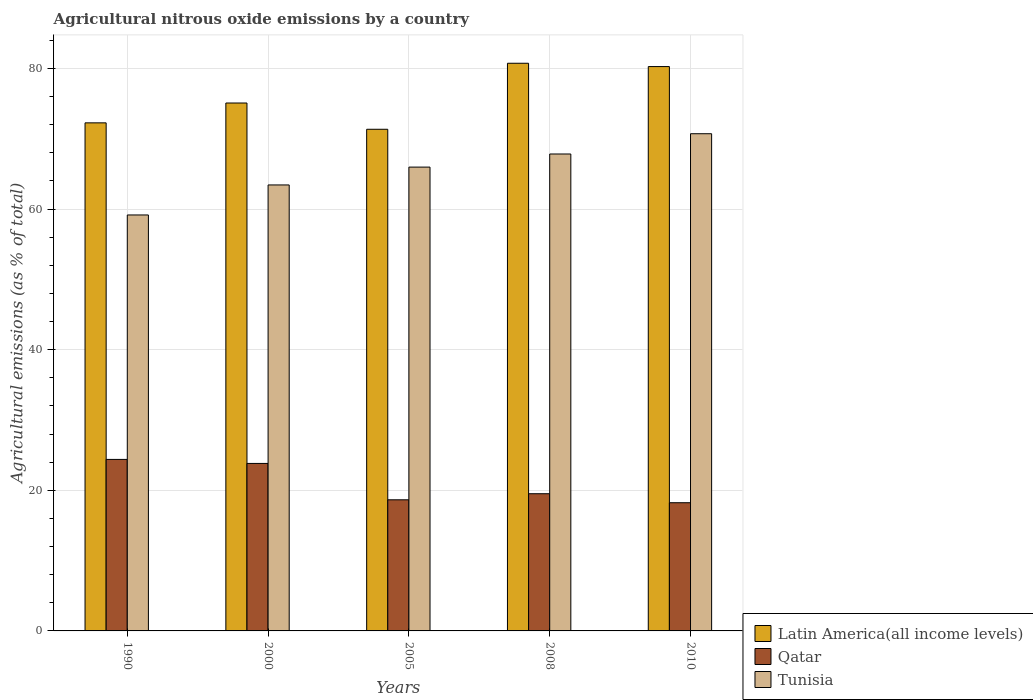How many groups of bars are there?
Your response must be concise. 5. Are the number of bars on each tick of the X-axis equal?
Give a very brief answer. Yes. How many bars are there on the 5th tick from the left?
Offer a terse response. 3. What is the label of the 3rd group of bars from the left?
Your answer should be very brief. 2005. What is the amount of agricultural nitrous oxide emitted in Qatar in 2010?
Ensure brevity in your answer.  18.23. Across all years, what is the maximum amount of agricultural nitrous oxide emitted in Latin America(all income levels)?
Offer a terse response. 80.73. Across all years, what is the minimum amount of agricultural nitrous oxide emitted in Qatar?
Keep it short and to the point. 18.23. What is the total amount of agricultural nitrous oxide emitted in Tunisia in the graph?
Offer a very short reply. 327.08. What is the difference between the amount of agricultural nitrous oxide emitted in Tunisia in 2005 and that in 2008?
Offer a terse response. -1.86. What is the difference between the amount of agricultural nitrous oxide emitted in Qatar in 2008 and the amount of agricultural nitrous oxide emitted in Tunisia in 1990?
Offer a very short reply. -39.64. What is the average amount of agricultural nitrous oxide emitted in Latin America(all income levels) per year?
Give a very brief answer. 75.93. In the year 2005, what is the difference between the amount of agricultural nitrous oxide emitted in Qatar and amount of agricultural nitrous oxide emitted in Tunisia?
Provide a succinct answer. -47.31. In how many years, is the amount of agricultural nitrous oxide emitted in Tunisia greater than 72 %?
Your answer should be very brief. 0. What is the ratio of the amount of agricultural nitrous oxide emitted in Latin America(all income levels) in 1990 to that in 2005?
Ensure brevity in your answer.  1.01. Is the difference between the amount of agricultural nitrous oxide emitted in Qatar in 1990 and 2010 greater than the difference between the amount of agricultural nitrous oxide emitted in Tunisia in 1990 and 2010?
Keep it short and to the point. Yes. What is the difference between the highest and the second highest amount of agricultural nitrous oxide emitted in Qatar?
Your answer should be very brief. 0.57. What is the difference between the highest and the lowest amount of agricultural nitrous oxide emitted in Tunisia?
Offer a very short reply. 11.55. In how many years, is the amount of agricultural nitrous oxide emitted in Tunisia greater than the average amount of agricultural nitrous oxide emitted in Tunisia taken over all years?
Your answer should be very brief. 3. What does the 2nd bar from the left in 2005 represents?
Ensure brevity in your answer.  Qatar. What does the 2nd bar from the right in 2005 represents?
Keep it short and to the point. Qatar. How many years are there in the graph?
Offer a very short reply. 5. Does the graph contain any zero values?
Offer a very short reply. No. Does the graph contain grids?
Provide a succinct answer. Yes. How many legend labels are there?
Offer a terse response. 3. How are the legend labels stacked?
Offer a very short reply. Vertical. What is the title of the graph?
Your answer should be very brief. Agricultural nitrous oxide emissions by a country. What is the label or title of the Y-axis?
Give a very brief answer. Agricultural emissions (as % of total). What is the Agricultural emissions (as % of total) of Latin America(all income levels) in 1990?
Offer a very short reply. 72.26. What is the Agricultural emissions (as % of total) in Qatar in 1990?
Ensure brevity in your answer.  24.39. What is the Agricultural emissions (as % of total) in Tunisia in 1990?
Give a very brief answer. 59.15. What is the Agricultural emissions (as % of total) in Latin America(all income levels) in 2000?
Provide a succinct answer. 75.08. What is the Agricultural emissions (as % of total) of Qatar in 2000?
Your answer should be very brief. 23.82. What is the Agricultural emissions (as % of total) in Tunisia in 2000?
Give a very brief answer. 63.42. What is the Agricultural emissions (as % of total) in Latin America(all income levels) in 2005?
Your response must be concise. 71.34. What is the Agricultural emissions (as % of total) of Qatar in 2005?
Offer a very short reply. 18.65. What is the Agricultural emissions (as % of total) in Tunisia in 2005?
Provide a short and direct response. 65.96. What is the Agricultural emissions (as % of total) in Latin America(all income levels) in 2008?
Ensure brevity in your answer.  80.73. What is the Agricultural emissions (as % of total) of Qatar in 2008?
Your response must be concise. 19.51. What is the Agricultural emissions (as % of total) in Tunisia in 2008?
Your answer should be very brief. 67.83. What is the Agricultural emissions (as % of total) of Latin America(all income levels) in 2010?
Make the answer very short. 80.26. What is the Agricultural emissions (as % of total) of Qatar in 2010?
Your answer should be compact. 18.23. What is the Agricultural emissions (as % of total) of Tunisia in 2010?
Give a very brief answer. 70.71. Across all years, what is the maximum Agricultural emissions (as % of total) of Latin America(all income levels)?
Keep it short and to the point. 80.73. Across all years, what is the maximum Agricultural emissions (as % of total) in Qatar?
Provide a short and direct response. 24.39. Across all years, what is the maximum Agricultural emissions (as % of total) of Tunisia?
Your answer should be compact. 70.71. Across all years, what is the minimum Agricultural emissions (as % of total) in Latin America(all income levels)?
Ensure brevity in your answer.  71.34. Across all years, what is the minimum Agricultural emissions (as % of total) in Qatar?
Ensure brevity in your answer.  18.23. Across all years, what is the minimum Agricultural emissions (as % of total) in Tunisia?
Provide a succinct answer. 59.15. What is the total Agricultural emissions (as % of total) of Latin America(all income levels) in the graph?
Your answer should be very brief. 379.66. What is the total Agricultural emissions (as % of total) in Qatar in the graph?
Offer a very short reply. 104.6. What is the total Agricultural emissions (as % of total) in Tunisia in the graph?
Ensure brevity in your answer.  327.08. What is the difference between the Agricultural emissions (as % of total) of Latin America(all income levels) in 1990 and that in 2000?
Give a very brief answer. -2.82. What is the difference between the Agricultural emissions (as % of total) of Qatar in 1990 and that in 2000?
Make the answer very short. 0.57. What is the difference between the Agricultural emissions (as % of total) in Tunisia in 1990 and that in 2000?
Provide a succinct answer. -4.27. What is the difference between the Agricultural emissions (as % of total) in Latin America(all income levels) in 1990 and that in 2005?
Ensure brevity in your answer.  0.91. What is the difference between the Agricultural emissions (as % of total) of Qatar in 1990 and that in 2005?
Your response must be concise. 5.74. What is the difference between the Agricultural emissions (as % of total) of Tunisia in 1990 and that in 2005?
Provide a short and direct response. -6.81. What is the difference between the Agricultural emissions (as % of total) of Latin America(all income levels) in 1990 and that in 2008?
Give a very brief answer. -8.47. What is the difference between the Agricultural emissions (as % of total) of Qatar in 1990 and that in 2008?
Make the answer very short. 4.88. What is the difference between the Agricultural emissions (as % of total) in Tunisia in 1990 and that in 2008?
Give a very brief answer. -8.67. What is the difference between the Agricultural emissions (as % of total) of Latin America(all income levels) in 1990 and that in 2010?
Ensure brevity in your answer.  -8. What is the difference between the Agricultural emissions (as % of total) of Qatar in 1990 and that in 2010?
Offer a very short reply. 6.16. What is the difference between the Agricultural emissions (as % of total) of Tunisia in 1990 and that in 2010?
Ensure brevity in your answer.  -11.55. What is the difference between the Agricultural emissions (as % of total) of Latin America(all income levels) in 2000 and that in 2005?
Offer a very short reply. 3.74. What is the difference between the Agricultural emissions (as % of total) in Qatar in 2000 and that in 2005?
Keep it short and to the point. 5.17. What is the difference between the Agricultural emissions (as % of total) of Tunisia in 2000 and that in 2005?
Your response must be concise. -2.54. What is the difference between the Agricultural emissions (as % of total) in Latin America(all income levels) in 2000 and that in 2008?
Offer a very short reply. -5.65. What is the difference between the Agricultural emissions (as % of total) in Qatar in 2000 and that in 2008?
Offer a very short reply. 4.31. What is the difference between the Agricultural emissions (as % of total) of Tunisia in 2000 and that in 2008?
Ensure brevity in your answer.  -4.4. What is the difference between the Agricultural emissions (as % of total) in Latin America(all income levels) in 2000 and that in 2010?
Your answer should be very brief. -5.18. What is the difference between the Agricultural emissions (as % of total) in Qatar in 2000 and that in 2010?
Keep it short and to the point. 5.59. What is the difference between the Agricultural emissions (as % of total) in Tunisia in 2000 and that in 2010?
Provide a succinct answer. -7.28. What is the difference between the Agricultural emissions (as % of total) in Latin America(all income levels) in 2005 and that in 2008?
Your answer should be very brief. -9.39. What is the difference between the Agricultural emissions (as % of total) of Qatar in 2005 and that in 2008?
Ensure brevity in your answer.  -0.86. What is the difference between the Agricultural emissions (as % of total) in Tunisia in 2005 and that in 2008?
Your answer should be compact. -1.86. What is the difference between the Agricultural emissions (as % of total) in Latin America(all income levels) in 2005 and that in 2010?
Your answer should be compact. -8.92. What is the difference between the Agricultural emissions (as % of total) in Qatar in 2005 and that in 2010?
Your answer should be compact. 0.42. What is the difference between the Agricultural emissions (as % of total) of Tunisia in 2005 and that in 2010?
Your response must be concise. -4.75. What is the difference between the Agricultural emissions (as % of total) of Latin America(all income levels) in 2008 and that in 2010?
Provide a succinct answer. 0.47. What is the difference between the Agricultural emissions (as % of total) of Qatar in 2008 and that in 2010?
Ensure brevity in your answer.  1.28. What is the difference between the Agricultural emissions (as % of total) in Tunisia in 2008 and that in 2010?
Offer a very short reply. -2.88. What is the difference between the Agricultural emissions (as % of total) of Latin America(all income levels) in 1990 and the Agricultural emissions (as % of total) of Qatar in 2000?
Provide a succinct answer. 48.43. What is the difference between the Agricultural emissions (as % of total) of Latin America(all income levels) in 1990 and the Agricultural emissions (as % of total) of Tunisia in 2000?
Make the answer very short. 8.83. What is the difference between the Agricultural emissions (as % of total) of Qatar in 1990 and the Agricultural emissions (as % of total) of Tunisia in 2000?
Your response must be concise. -39.03. What is the difference between the Agricultural emissions (as % of total) in Latin America(all income levels) in 1990 and the Agricultural emissions (as % of total) in Qatar in 2005?
Offer a very short reply. 53.61. What is the difference between the Agricultural emissions (as % of total) of Latin America(all income levels) in 1990 and the Agricultural emissions (as % of total) of Tunisia in 2005?
Your response must be concise. 6.29. What is the difference between the Agricultural emissions (as % of total) of Qatar in 1990 and the Agricultural emissions (as % of total) of Tunisia in 2005?
Give a very brief answer. -41.57. What is the difference between the Agricultural emissions (as % of total) of Latin America(all income levels) in 1990 and the Agricultural emissions (as % of total) of Qatar in 2008?
Offer a terse response. 52.74. What is the difference between the Agricultural emissions (as % of total) in Latin America(all income levels) in 1990 and the Agricultural emissions (as % of total) in Tunisia in 2008?
Offer a terse response. 4.43. What is the difference between the Agricultural emissions (as % of total) in Qatar in 1990 and the Agricultural emissions (as % of total) in Tunisia in 2008?
Give a very brief answer. -43.44. What is the difference between the Agricultural emissions (as % of total) of Latin America(all income levels) in 1990 and the Agricultural emissions (as % of total) of Qatar in 2010?
Offer a terse response. 54.02. What is the difference between the Agricultural emissions (as % of total) in Latin America(all income levels) in 1990 and the Agricultural emissions (as % of total) in Tunisia in 2010?
Provide a short and direct response. 1.55. What is the difference between the Agricultural emissions (as % of total) in Qatar in 1990 and the Agricultural emissions (as % of total) in Tunisia in 2010?
Your answer should be very brief. -46.32. What is the difference between the Agricultural emissions (as % of total) in Latin America(all income levels) in 2000 and the Agricultural emissions (as % of total) in Qatar in 2005?
Give a very brief answer. 56.43. What is the difference between the Agricultural emissions (as % of total) of Latin America(all income levels) in 2000 and the Agricultural emissions (as % of total) of Tunisia in 2005?
Keep it short and to the point. 9.12. What is the difference between the Agricultural emissions (as % of total) of Qatar in 2000 and the Agricultural emissions (as % of total) of Tunisia in 2005?
Keep it short and to the point. -42.14. What is the difference between the Agricultural emissions (as % of total) of Latin America(all income levels) in 2000 and the Agricultural emissions (as % of total) of Qatar in 2008?
Offer a terse response. 55.57. What is the difference between the Agricultural emissions (as % of total) in Latin America(all income levels) in 2000 and the Agricultural emissions (as % of total) in Tunisia in 2008?
Your response must be concise. 7.25. What is the difference between the Agricultural emissions (as % of total) of Qatar in 2000 and the Agricultural emissions (as % of total) of Tunisia in 2008?
Make the answer very short. -44.01. What is the difference between the Agricultural emissions (as % of total) in Latin America(all income levels) in 2000 and the Agricultural emissions (as % of total) in Qatar in 2010?
Make the answer very short. 56.85. What is the difference between the Agricultural emissions (as % of total) of Latin America(all income levels) in 2000 and the Agricultural emissions (as % of total) of Tunisia in 2010?
Your answer should be very brief. 4.37. What is the difference between the Agricultural emissions (as % of total) of Qatar in 2000 and the Agricultural emissions (as % of total) of Tunisia in 2010?
Ensure brevity in your answer.  -46.89. What is the difference between the Agricultural emissions (as % of total) in Latin America(all income levels) in 2005 and the Agricultural emissions (as % of total) in Qatar in 2008?
Provide a succinct answer. 51.83. What is the difference between the Agricultural emissions (as % of total) in Latin America(all income levels) in 2005 and the Agricultural emissions (as % of total) in Tunisia in 2008?
Provide a succinct answer. 3.52. What is the difference between the Agricultural emissions (as % of total) in Qatar in 2005 and the Agricultural emissions (as % of total) in Tunisia in 2008?
Keep it short and to the point. -49.18. What is the difference between the Agricultural emissions (as % of total) in Latin America(all income levels) in 2005 and the Agricultural emissions (as % of total) in Qatar in 2010?
Ensure brevity in your answer.  53.11. What is the difference between the Agricultural emissions (as % of total) in Latin America(all income levels) in 2005 and the Agricultural emissions (as % of total) in Tunisia in 2010?
Give a very brief answer. 0.63. What is the difference between the Agricultural emissions (as % of total) in Qatar in 2005 and the Agricultural emissions (as % of total) in Tunisia in 2010?
Your answer should be compact. -52.06. What is the difference between the Agricultural emissions (as % of total) in Latin America(all income levels) in 2008 and the Agricultural emissions (as % of total) in Qatar in 2010?
Your answer should be compact. 62.5. What is the difference between the Agricultural emissions (as % of total) in Latin America(all income levels) in 2008 and the Agricultural emissions (as % of total) in Tunisia in 2010?
Provide a short and direct response. 10.02. What is the difference between the Agricultural emissions (as % of total) in Qatar in 2008 and the Agricultural emissions (as % of total) in Tunisia in 2010?
Provide a succinct answer. -51.2. What is the average Agricultural emissions (as % of total) in Latin America(all income levels) per year?
Ensure brevity in your answer.  75.93. What is the average Agricultural emissions (as % of total) of Qatar per year?
Provide a short and direct response. 20.92. What is the average Agricultural emissions (as % of total) of Tunisia per year?
Offer a terse response. 65.42. In the year 1990, what is the difference between the Agricultural emissions (as % of total) in Latin America(all income levels) and Agricultural emissions (as % of total) in Qatar?
Provide a short and direct response. 47.86. In the year 1990, what is the difference between the Agricultural emissions (as % of total) of Latin America(all income levels) and Agricultural emissions (as % of total) of Tunisia?
Your answer should be very brief. 13.1. In the year 1990, what is the difference between the Agricultural emissions (as % of total) in Qatar and Agricultural emissions (as % of total) in Tunisia?
Provide a short and direct response. -34.76. In the year 2000, what is the difference between the Agricultural emissions (as % of total) of Latin America(all income levels) and Agricultural emissions (as % of total) of Qatar?
Provide a short and direct response. 51.26. In the year 2000, what is the difference between the Agricultural emissions (as % of total) of Latin America(all income levels) and Agricultural emissions (as % of total) of Tunisia?
Your response must be concise. 11.65. In the year 2000, what is the difference between the Agricultural emissions (as % of total) of Qatar and Agricultural emissions (as % of total) of Tunisia?
Give a very brief answer. -39.6. In the year 2005, what is the difference between the Agricultural emissions (as % of total) of Latin America(all income levels) and Agricultural emissions (as % of total) of Qatar?
Your answer should be compact. 52.69. In the year 2005, what is the difference between the Agricultural emissions (as % of total) in Latin America(all income levels) and Agricultural emissions (as % of total) in Tunisia?
Offer a terse response. 5.38. In the year 2005, what is the difference between the Agricultural emissions (as % of total) in Qatar and Agricultural emissions (as % of total) in Tunisia?
Make the answer very short. -47.31. In the year 2008, what is the difference between the Agricultural emissions (as % of total) in Latin America(all income levels) and Agricultural emissions (as % of total) in Qatar?
Your answer should be compact. 61.22. In the year 2008, what is the difference between the Agricultural emissions (as % of total) in Latin America(all income levels) and Agricultural emissions (as % of total) in Tunisia?
Provide a short and direct response. 12.9. In the year 2008, what is the difference between the Agricultural emissions (as % of total) in Qatar and Agricultural emissions (as % of total) in Tunisia?
Your answer should be very brief. -48.32. In the year 2010, what is the difference between the Agricultural emissions (as % of total) in Latin America(all income levels) and Agricultural emissions (as % of total) in Qatar?
Give a very brief answer. 62.03. In the year 2010, what is the difference between the Agricultural emissions (as % of total) of Latin America(all income levels) and Agricultural emissions (as % of total) of Tunisia?
Provide a short and direct response. 9.55. In the year 2010, what is the difference between the Agricultural emissions (as % of total) in Qatar and Agricultural emissions (as % of total) in Tunisia?
Make the answer very short. -52.48. What is the ratio of the Agricultural emissions (as % of total) in Latin America(all income levels) in 1990 to that in 2000?
Provide a short and direct response. 0.96. What is the ratio of the Agricultural emissions (as % of total) of Qatar in 1990 to that in 2000?
Give a very brief answer. 1.02. What is the ratio of the Agricultural emissions (as % of total) of Tunisia in 1990 to that in 2000?
Ensure brevity in your answer.  0.93. What is the ratio of the Agricultural emissions (as % of total) in Latin America(all income levels) in 1990 to that in 2005?
Your answer should be compact. 1.01. What is the ratio of the Agricultural emissions (as % of total) of Qatar in 1990 to that in 2005?
Offer a very short reply. 1.31. What is the ratio of the Agricultural emissions (as % of total) of Tunisia in 1990 to that in 2005?
Your answer should be compact. 0.9. What is the ratio of the Agricultural emissions (as % of total) in Latin America(all income levels) in 1990 to that in 2008?
Your answer should be compact. 0.9. What is the ratio of the Agricultural emissions (as % of total) in Qatar in 1990 to that in 2008?
Offer a terse response. 1.25. What is the ratio of the Agricultural emissions (as % of total) of Tunisia in 1990 to that in 2008?
Make the answer very short. 0.87. What is the ratio of the Agricultural emissions (as % of total) in Latin America(all income levels) in 1990 to that in 2010?
Keep it short and to the point. 0.9. What is the ratio of the Agricultural emissions (as % of total) in Qatar in 1990 to that in 2010?
Ensure brevity in your answer.  1.34. What is the ratio of the Agricultural emissions (as % of total) of Tunisia in 1990 to that in 2010?
Your answer should be compact. 0.84. What is the ratio of the Agricultural emissions (as % of total) in Latin America(all income levels) in 2000 to that in 2005?
Your answer should be compact. 1.05. What is the ratio of the Agricultural emissions (as % of total) in Qatar in 2000 to that in 2005?
Make the answer very short. 1.28. What is the ratio of the Agricultural emissions (as % of total) in Tunisia in 2000 to that in 2005?
Your answer should be very brief. 0.96. What is the ratio of the Agricultural emissions (as % of total) of Qatar in 2000 to that in 2008?
Your response must be concise. 1.22. What is the ratio of the Agricultural emissions (as % of total) in Tunisia in 2000 to that in 2008?
Give a very brief answer. 0.94. What is the ratio of the Agricultural emissions (as % of total) of Latin America(all income levels) in 2000 to that in 2010?
Your response must be concise. 0.94. What is the ratio of the Agricultural emissions (as % of total) of Qatar in 2000 to that in 2010?
Provide a short and direct response. 1.31. What is the ratio of the Agricultural emissions (as % of total) in Tunisia in 2000 to that in 2010?
Offer a terse response. 0.9. What is the ratio of the Agricultural emissions (as % of total) in Latin America(all income levels) in 2005 to that in 2008?
Provide a succinct answer. 0.88. What is the ratio of the Agricultural emissions (as % of total) of Qatar in 2005 to that in 2008?
Ensure brevity in your answer.  0.96. What is the ratio of the Agricultural emissions (as % of total) in Tunisia in 2005 to that in 2008?
Make the answer very short. 0.97. What is the ratio of the Agricultural emissions (as % of total) of Latin America(all income levels) in 2005 to that in 2010?
Make the answer very short. 0.89. What is the ratio of the Agricultural emissions (as % of total) in Qatar in 2005 to that in 2010?
Provide a succinct answer. 1.02. What is the ratio of the Agricultural emissions (as % of total) of Tunisia in 2005 to that in 2010?
Offer a terse response. 0.93. What is the ratio of the Agricultural emissions (as % of total) of Latin America(all income levels) in 2008 to that in 2010?
Your response must be concise. 1.01. What is the ratio of the Agricultural emissions (as % of total) in Qatar in 2008 to that in 2010?
Offer a terse response. 1.07. What is the ratio of the Agricultural emissions (as % of total) in Tunisia in 2008 to that in 2010?
Your answer should be very brief. 0.96. What is the difference between the highest and the second highest Agricultural emissions (as % of total) of Latin America(all income levels)?
Keep it short and to the point. 0.47. What is the difference between the highest and the second highest Agricultural emissions (as % of total) in Qatar?
Your answer should be very brief. 0.57. What is the difference between the highest and the second highest Agricultural emissions (as % of total) in Tunisia?
Provide a succinct answer. 2.88. What is the difference between the highest and the lowest Agricultural emissions (as % of total) in Latin America(all income levels)?
Provide a succinct answer. 9.39. What is the difference between the highest and the lowest Agricultural emissions (as % of total) of Qatar?
Make the answer very short. 6.16. What is the difference between the highest and the lowest Agricultural emissions (as % of total) of Tunisia?
Your answer should be compact. 11.55. 